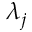Convert formula to latex. <formula><loc_0><loc_0><loc_500><loc_500>\lambda _ { j }</formula> 